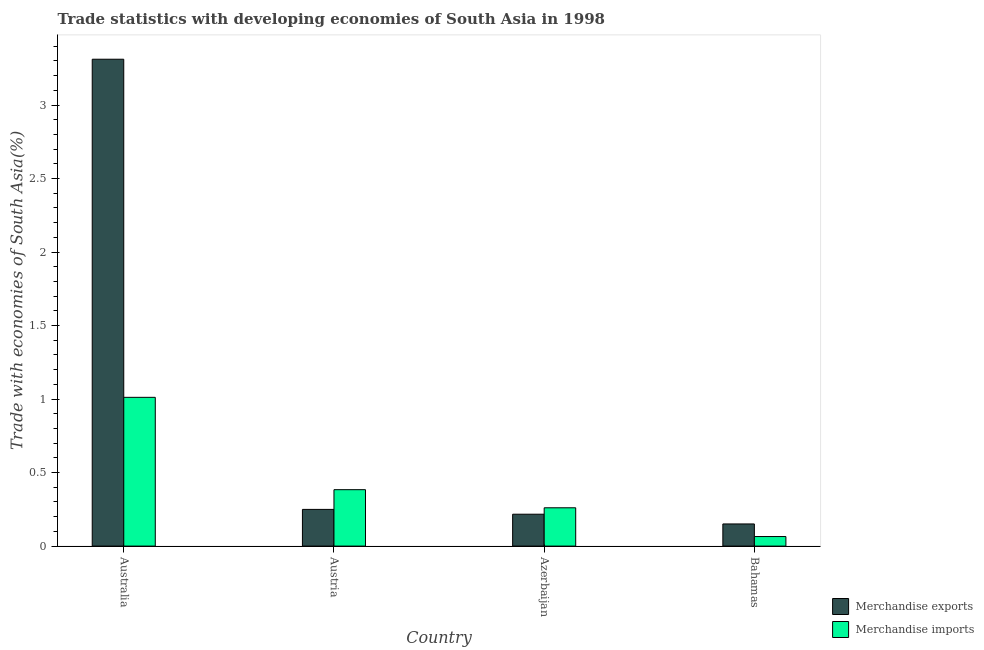How many different coloured bars are there?
Your answer should be very brief. 2. How many groups of bars are there?
Provide a succinct answer. 4. Are the number of bars per tick equal to the number of legend labels?
Your answer should be compact. Yes. How many bars are there on the 1st tick from the left?
Make the answer very short. 2. What is the label of the 2nd group of bars from the left?
Your answer should be compact. Austria. What is the merchandise exports in Austria?
Your answer should be compact. 0.25. Across all countries, what is the maximum merchandise imports?
Your answer should be very brief. 1.01. Across all countries, what is the minimum merchandise exports?
Offer a terse response. 0.15. In which country was the merchandise imports minimum?
Make the answer very short. Bahamas. What is the total merchandise imports in the graph?
Provide a succinct answer. 1.72. What is the difference between the merchandise imports in Austria and that in Azerbaijan?
Provide a short and direct response. 0.12. What is the difference between the merchandise exports in Azerbaijan and the merchandise imports in Austria?
Keep it short and to the point. -0.17. What is the average merchandise imports per country?
Your answer should be very brief. 0.43. What is the difference between the merchandise imports and merchandise exports in Australia?
Your response must be concise. -2.3. What is the ratio of the merchandise exports in Australia to that in Azerbaijan?
Your response must be concise. 15.27. Is the merchandise imports in Australia less than that in Azerbaijan?
Provide a short and direct response. No. Is the difference between the merchandise exports in Azerbaijan and Bahamas greater than the difference between the merchandise imports in Azerbaijan and Bahamas?
Your response must be concise. No. What is the difference between the highest and the second highest merchandise imports?
Offer a terse response. 0.63. What is the difference between the highest and the lowest merchandise imports?
Make the answer very short. 0.95. What does the 2nd bar from the left in Azerbaijan represents?
Offer a terse response. Merchandise imports. Does the graph contain any zero values?
Offer a terse response. No. Does the graph contain grids?
Give a very brief answer. No. Where does the legend appear in the graph?
Provide a succinct answer. Bottom right. How are the legend labels stacked?
Offer a very short reply. Vertical. What is the title of the graph?
Offer a very short reply. Trade statistics with developing economies of South Asia in 1998. Does "Current education expenditure" appear as one of the legend labels in the graph?
Make the answer very short. No. What is the label or title of the Y-axis?
Your answer should be compact. Trade with economies of South Asia(%). What is the Trade with economies of South Asia(%) in Merchandise exports in Australia?
Provide a succinct answer. 3.31. What is the Trade with economies of South Asia(%) in Merchandise imports in Australia?
Your answer should be very brief. 1.01. What is the Trade with economies of South Asia(%) of Merchandise exports in Austria?
Keep it short and to the point. 0.25. What is the Trade with economies of South Asia(%) of Merchandise imports in Austria?
Give a very brief answer. 0.38. What is the Trade with economies of South Asia(%) in Merchandise exports in Azerbaijan?
Your answer should be compact. 0.22. What is the Trade with economies of South Asia(%) in Merchandise imports in Azerbaijan?
Give a very brief answer. 0.26. What is the Trade with economies of South Asia(%) of Merchandise exports in Bahamas?
Keep it short and to the point. 0.15. What is the Trade with economies of South Asia(%) of Merchandise imports in Bahamas?
Make the answer very short. 0.07. Across all countries, what is the maximum Trade with economies of South Asia(%) in Merchandise exports?
Provide a short and direct response. 3.31. Across all countries, what is the maximum Trade with economies of South Asia(%) of Merchandise imports?
Your answer should be very brief. 1.01. Across all countries, what is the minimum Trade with economies of South Asia(%) in Merchandise exports?
Give a very brief answer. 0.15. Across all countries, what is the minimum Trade with economies of South Asia(%) of Merchandise imports?
Give a very brief answer. 0.07. What is the total Trade with economies of South Asia(%) in Merchandise exports in the graph?
Offer a very short reply. 3.93. What is the total Trade with economies of South Asia(%) of Merchandise imports in the graph?
Offer a very short reply. 1.72. What is the difference between the Trade with economies of South Asia(%) in Merchandise exports in Australia and that in Austria?
Your answer should be very brief. 3.06. What is the difference between the Trade with economies of South Asia(%) in Merchandise imports in Australia and that in Austria?
Your response must be concise. 0.63. What is the difference between the Trade with economies of South Asia(%) of Merchandise exports in Australia and that in Azerbaijan?
Offer a terse response. 3.1. What is the difference between the Trade with economies of South Asia(%) in Merchandise imports in Australia and that in Azerbaijan?
Make the answer very short. 0.75. What is the difference between the Trade with economies of South Asia(%) in Merchandise exports in Australia and that in Bahamas?
Your response must be concise. 3.16. What is the difference between the Trade with economies of South Asia(%) of Merchandise imports in Australia and that in Bahamas?
Provide a short and direct response. 0.95. What is the difference between the Trade with economies of South Asia(%) in Merchandise exports in Austria and that in Azerbaijan?
Ensure brevity in your answer.  0.03. What is the difference between the Trade with economies of South Asia(%) of Merchandise imports in Austria and that in Azerbaijan?
Your answer should be compact. 0.12. What is the difference between the Trade with economies of South Asia(%) in Merchandise exports in Austria and that in Bahamas?
Your answer should be very brief. 0.1. What is the difference between the Trade with economies of South Asia(%) of Merchandise imports in Austria and that in Bahamas?
Your answer should be very brief. 0.32. What is the difference between the Trade with economies of South Asia(%) in Merchandise exports in Azerbaijan and that in Bahamas?
Your response must be concise. 0.07. What is the difference between the Trade with economies of South Asia(%) in Merchandise imports in Azerbaijan and that in Bahamas?
Give a very brief answer. 0.2. What is the difference between the Trade with economies of South Asia(%) of Merchandise exports in Australia and the Trade with economies of South Asia(%) of Merchandise imports in Austria?
Your answer should be compact. 2.93. What is the difference between the Trade with economies of South Asia(%) of Merchandise exports in Australia and the Trade with economies of South Asia(%) of Merchandise imports in Azerbaijan?
Give a very brief answer. 3.05. What is the difference between the Trade with economies of South Asia(%) of Merchandise exports in Australia and the Trade with economies of South Asia(%) of Merchandise imports in Bahamas?
Offer a very short reply. 3.25. What is the difference between the Trade with economies of South Asia(%) in Merchandise exports in Austria and the Trade with economies of South Asia(%) in Merchandise imports in Azerbaijan?
Offer a terse response. -0.01. What is the difference between the Trade with economies of South Asia(%) in Merchandise exports in Austria and the Trade with economies of South Asia(%) in Merchandise imports in Bahamas?
Ensure brevity in your answer.  0.18. What is the difference between the Trade with economies of South Asia(%) in Merchandise exports in Azerbaijan and the Trade with economies of South Asia(%) in Merchandise imports in Bahamas?
Offer a very short reply. 0.15. What is the average Trade with economies of South Asia(%) of Merchandise exports per country?
Keep it short and to the point. 0.98. What is the average Trade with economies of South Asia(%) of Merchandise imports per country?
Make the answer very short. 0.43. What is the difference between the Trade with economies of South Asia(%) in Merchandise exports and Trade with economies of South Asia(%) in Merchandise imports in Australia?
Give a very brief answer. 2.3. What is the difference between the Trade with economies of South Asia(%) in Merchandise exports and Trade with economies of South Asia(%) in Merchandise imports in Austria?
Give a very brief answer. -0.13. What is the difference between the Trade with economies of South Asia(%) in Merchandise exports and Trade with economies of South Asia(%) in Merchandise imports in Azerbaijan?
Keep it short and to the point. -0.04. What is the difference between the Trade with economies of South Asia(%) in Merchandise exports and Trade with economies of South Asia(%) in Merchandise imports in Bahamas?
Your answer should be very brief. 0.09. What is the ratio of the Trade with economies of South Asia(%) in Merchandise exports in Australia to that in Austria?
Offer a very short reply. 13.27. What is the ratio of the Trade with economies of South Asia(%) of Merchandise imports in Australia to that in Austria?
Keep it short and to the point. 2.64. What is the ratio of the Trade with economies of South Asia(%) of Merchandise exports in Australia to that in Azerbaijan?
Provide a short and direct response. 15.27. What is the ratio of the Trade with economies of South Asia(%) in Merchandise imports in Australia to that in Azerbaijan?
Offer a terse response. 3.88. What is the ratio of the Trade with economies of South Asia(%) of Merchandise exports in Australia to that in Bahamas?
Your answer should be compact. 21.98. What is the ratio of the Trade with economies of South Asia(%) of Merchandise imports in Australia to that in Bahamas?
Provide a succinct answer. 15.56. What is the ratio of the Trade with economies of South Asia(%) of Merchandise exports in Austria to that in Azerbaijan?
Give a very brief answer. 1.15. What is the ratio of the Trade with economies of South Asia(%) of Merchandise imports in Austria to that in Azerbaijan?
Offer a terse response. 1.47. What is the ratio of the Trade with economies of South Asia(%) in Merchandise exports in Austria to that in Bahamas?
Your answer should be very brief. 1.66. What is the ratio of the Trade with economies of South Asia(%) of Merchandise imports in Austria to that in Bahamas?
Your answer should be very brief. 5.9. What is the ratio of the Trade with economies of South Asia(%) of Merchandise exports in Azerbaijan to that in Bahamas?
Offer a terse response. 1.44. What is the ratio of the Trade with economies of South Asia(%) in Merchandise imports in Azerbaijan to that in Bahamas?
Give a very brief answer. 4.01. What is the difference between the highest and the second highest Trade with economies of South Asia(%) in Merchandise exports?
Ensure brevity in your answer.  3.06. What is the difference between the highest and the second highest Trade with economies of South Asia(%) of Merchandise imports?
Provide a short and direct response. 0.63. What is the difference between the highest and the lowest Trade with economies of South Asia(%) of Merchandise exports?
Make the answer very short. 3.16. What is the difference between the highest and the lowest Trade with economies of South Asia(%) in Merchandise imports?
Make the answer very short. 0.95. 